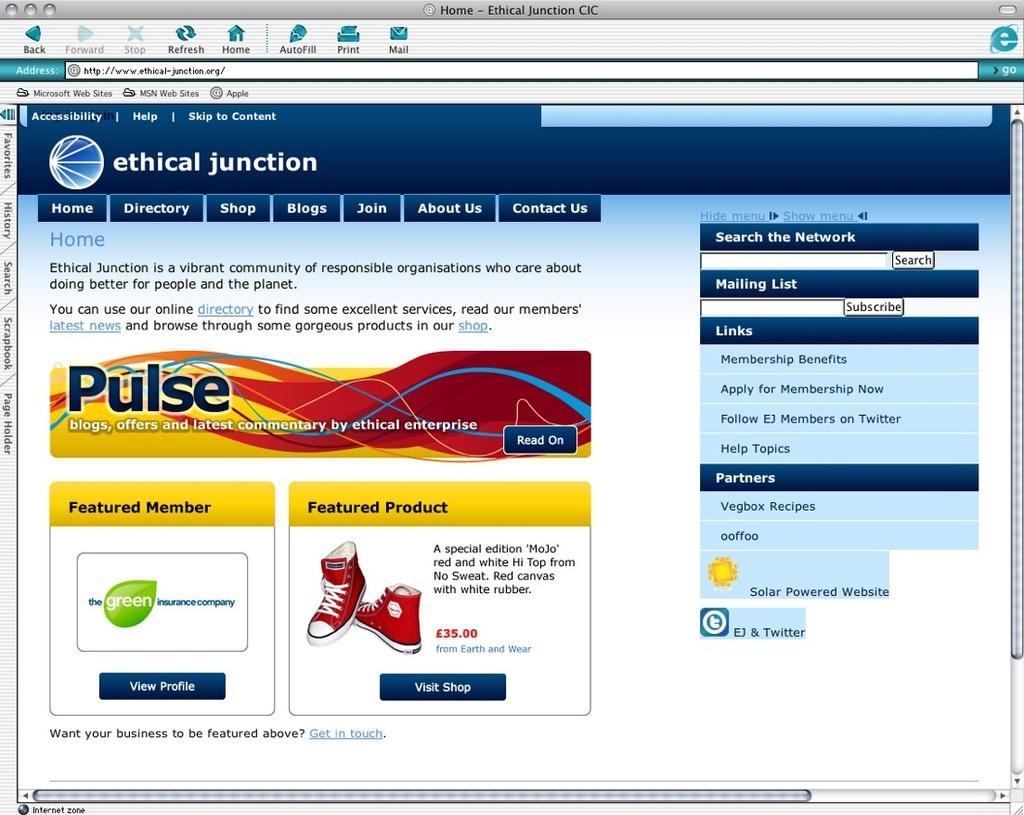What is the main object visible in the image? There is a monitor screen in the image. Can you describe the monitor screen in more detail? Unfortunately, the provided facts do not offer any additional details about the monitor screen. What type of acoustics can be heard coming from the monitor screen in the image? There is no sound or audio present in the image, as it only features a monitor screen. 